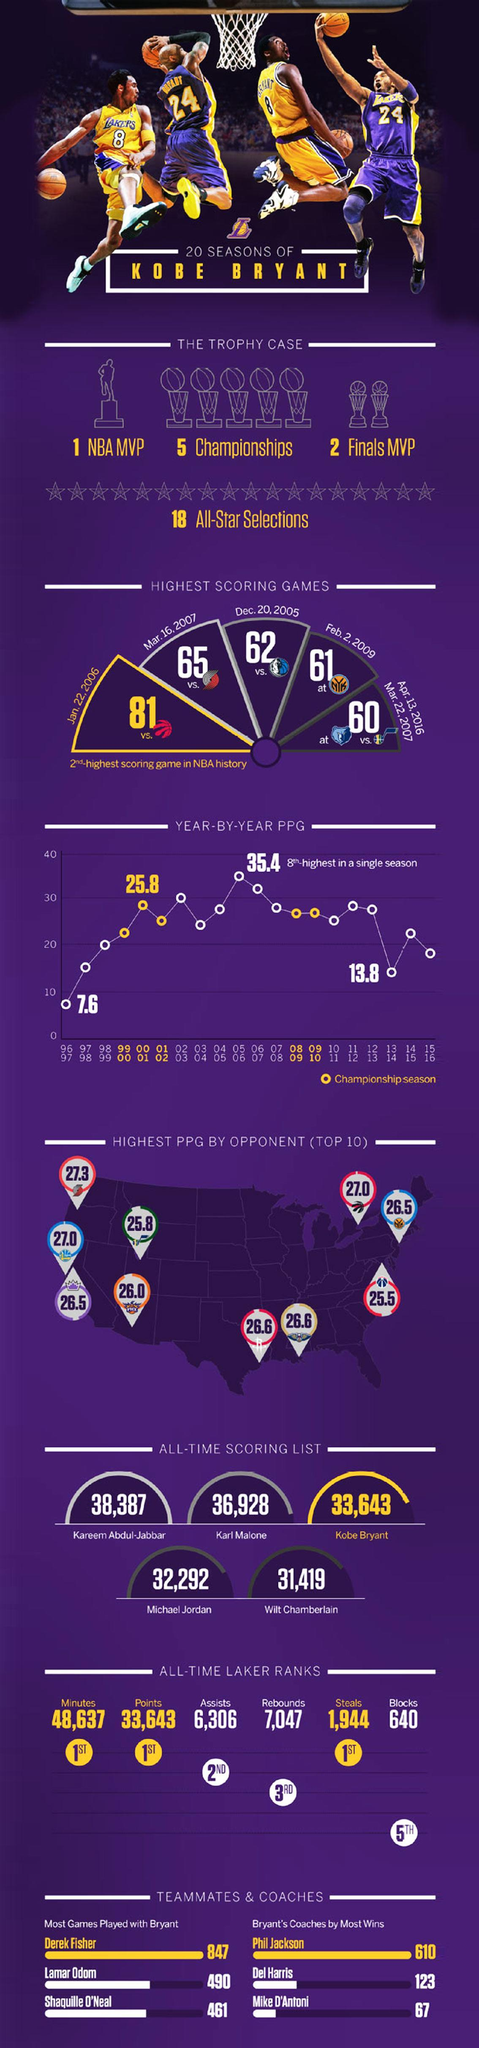Who was Kobe Bryant's coach for the most wins?
Answer the question with a short phrase. Phil Jackson What is the total point scored by Michael Jordan in his career? 32,292 What is the total point scored by Kobe Bryant in his career? 33,643 How many games were won by Kobe Bryant under the guidance of Dell Harris? 123 How many points were scored by Kobe Bryant in the game played on March 16, 2007? 65 